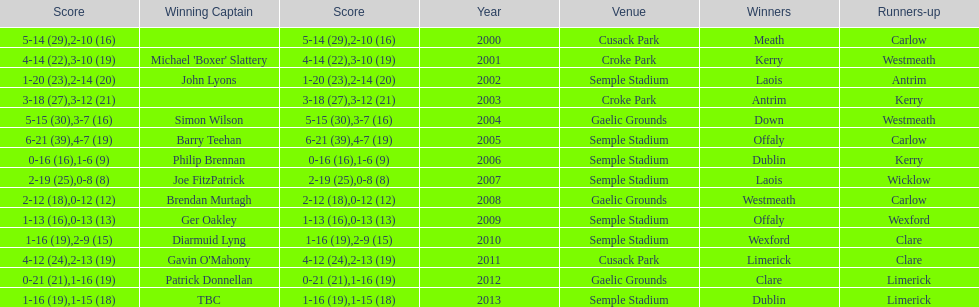What is the difference in the scores in 2000? 13. 